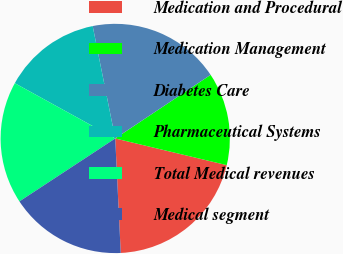Convert chart. <chart><loc_0><loc_0><loc_500><loc_500><pie_chart><fcel>Medication and Procedural<fcel>Medication Management<fcel>Diabetes Care<fcel>Pharmaceutical Systems<fcel>Total Medical revenues<fcel>Medical segment<nl><fcel>20.5%<fcel>13.1%<fcel>18.79%<fcel>13.84%<fcel>17.26%<fcel>16.51%<nl></chart> 